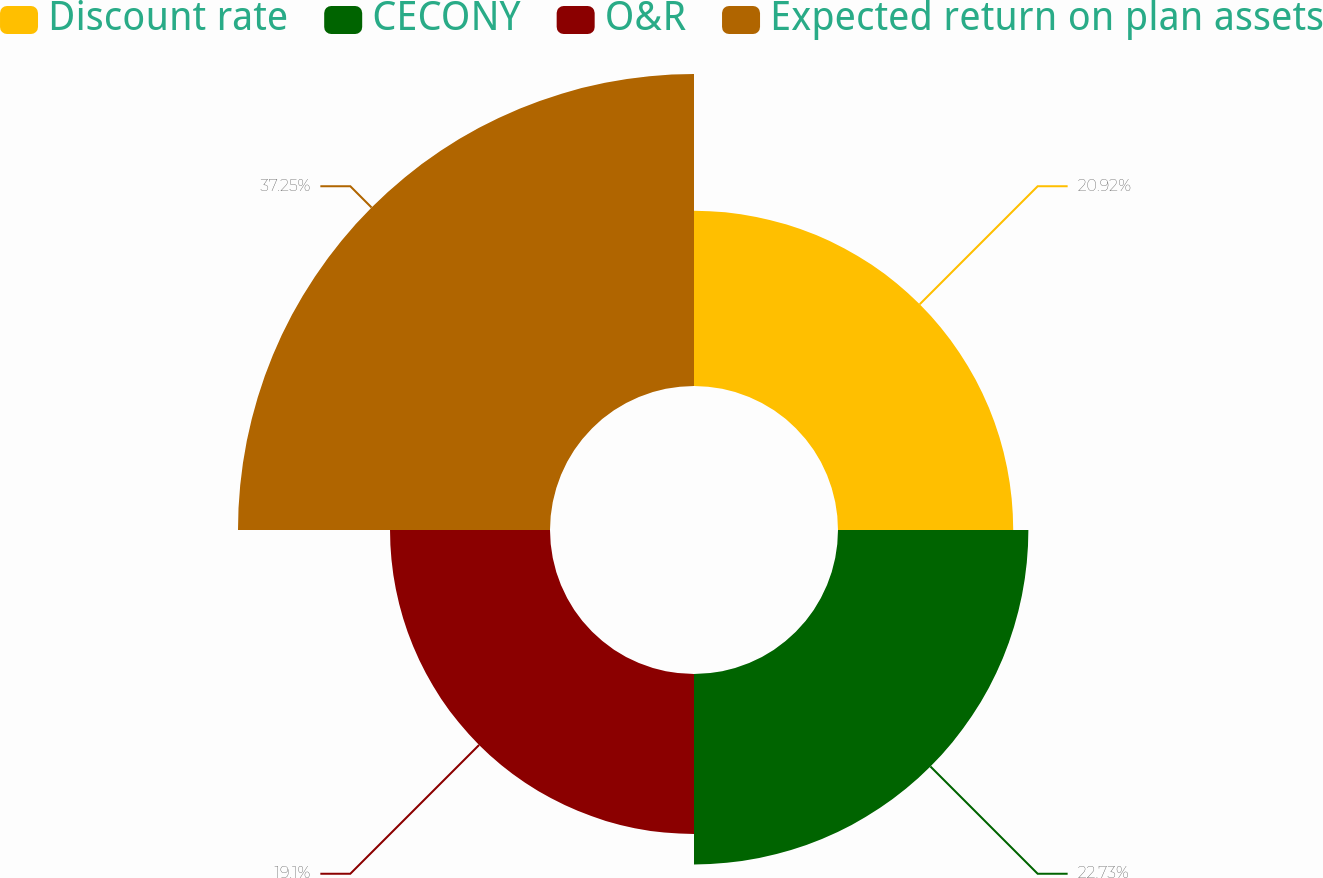Convert chart to OTSL. <chart><loc_0><loc_0><loc_500><loc_500><pie_chart><fcel>Discount rate<fcel>CECONY<fcel>O&R<fcel>Expected return on plan assets<nl><fcel>20.92%<fcel>22.73%<fcel>19.1%<fcel>37.25%<nl></chart> 